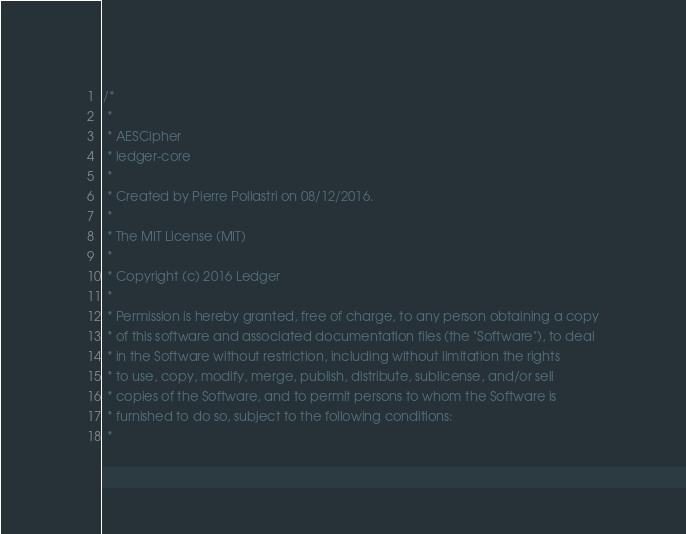Convert code to text. <code><loc_0><loc_0><loc_500><loc_500><_C++_>/*
 *
 * AESCipher
 * ledger-core
 *
 * Created by Pierre Pollastri on 08/12/2016.
 *
 * The MIT License (MIT)
 *
 * Copyright (c) 2016 Ledger
 *
 * Permission is hereby granted, free of charge, to any person obtaining a copy
 * of this software and associated documentation files (the "Software"), to deal
 * in the Software without restriction, including without limitation the rights
 * to use, copy, modify, merge, publish, distribute, sublicense, and/or sell
 * copies of the Software, and to permit persons to whom the Software is
 * furnished to do so, subject to the following conditions:
 *</code> 